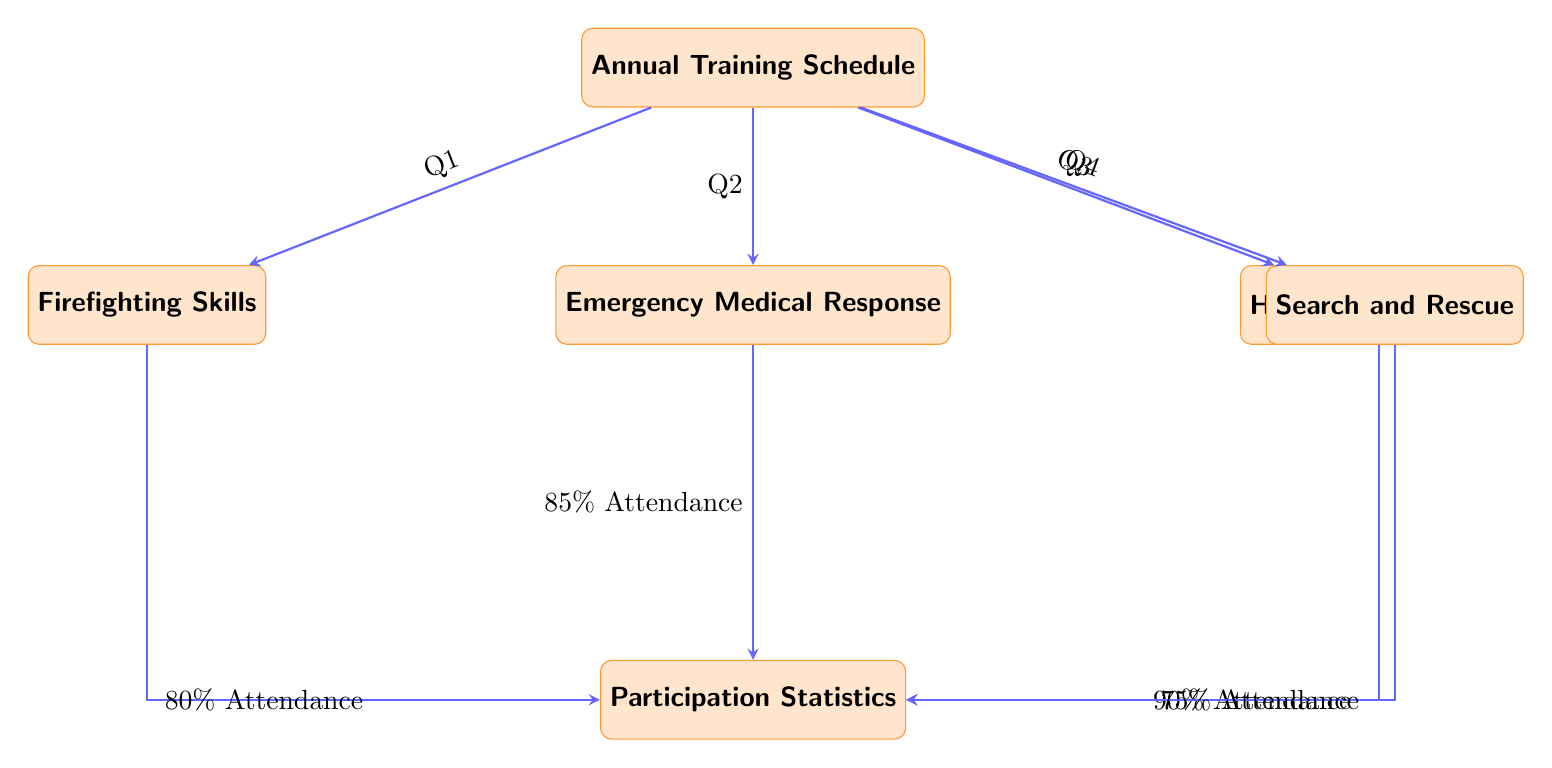What are the four training components listed in the diagram? The diagram lists four training components: Firefighting Skills, Emergency Medical Response, Hazardous Materials, and Search and Rescue. These are found in the nodes connected to the main node labeled Annual Training Schedule.
Answer: Firefighting Skills, Emergency Medical Response, Hazardous Materials, Search and Rescue Which quarter is dedicated to Hazardous Materials training? In the diagram, the node for Hazardous Materials is connected with an arrow labeled Q3, indicating that this training occurs during the third quarter.
Answer: Q3 What percentage attendance was reported for Emergency Medical Response training? The diagram shows that Emergency Medical Response has an arrow pointing to the Participation Statistics node with a label that indicates 85% Attendance. This information is directly noted by the arrow connection from the training type to the attendance statistic.
Answer: 85% Attendance Which training component has the lowest attendance participation? The diagram indicates the Participation Statistics for each training, and the lowest percentage is shown for Search and Rescue, which has 75% Attendance. By comparing the attendance figures linked to each training, Search and Rescue has the smallest value.
Answer: 75% Attendance What type of diagram is represented here? The representation shows a flowchart that outlines an Annual Training Schedule alongside participation statistics, fitting the characteristics typically associated with a Textbook Diagram. The presence of nodes and directional arrows signifies this type of diagram.
Answer: Textbook Diagram 